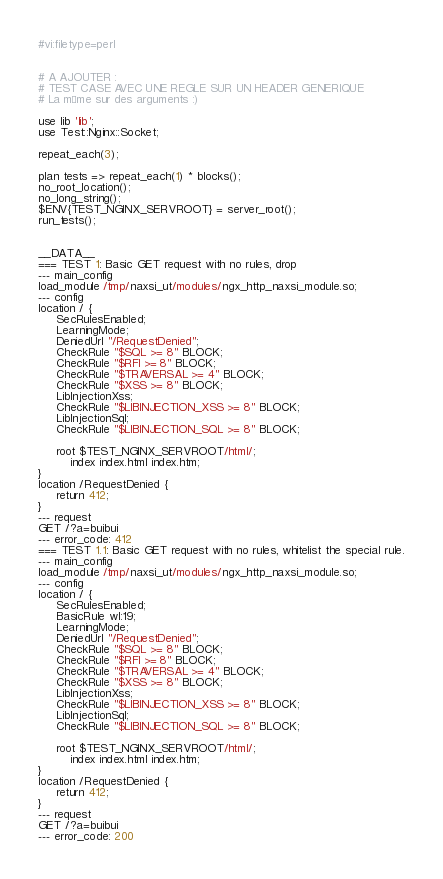Convert code to text. <code><loc_0><loc_0><loc_500><loc_500><_Perl_>#vi:filetype=perl


# A AJOUTER :
# TEST CASE AVEC UNE REGLE SUR UN HEADER GENERIQUE
# La même sur des arguments :)

use lib 'lib';
use Test::Nginx::Socket;

repeat_each(3);

plan tests => repeat_each(1) * blocks();
no_root_location();
no_long_string();
$ENV{TEST_NGINX_SERVROOT} = server_root();
run_tests();


__DATA__
=== TEST 1: Basic GET request with no rules, drop
--- main_config
load_module /tmp/naxsi_ut/modules/ngx_http_naxsi_module.so;
--- config
location / {
	 SecRulesEnabled;
	 LearningMode;
	 DeniedUrl "/RequestDenied";
	 CheckRule "$SQL >= 8" BLOCK;
	 CheckRule "$RFI >= 8" BLOCK;
	 CheckRule "$TRAVERSAL >= 4" BLOCK;
	 CheckRule "$XSS >= 8" BLOCK;
	 LibInjectionXss;
	 CheckRule "$LIBINJECTION_XSS >= 8" BLOCK;
	 LibInjectionSql;
	 CheckRule "$LIBINJECTION_SQL >= 8" BLOCK;

  	 root $TEST_NGINX_SERVROOT/html/;
         index index.html index.htm;
}
location /RequestDenied {
	 return 412;
}
--- request
GET /?a=buibui
--- error_code: 412
=== TEST 1.1: Basic GET request with no rules, whitelist the special rule.
--- main_config
load_module /tmp/naxsi_ut/modules/ngx_http_naxsi_module.so;
--- config
location / {
	 SecRulesEnabled;
	 BasicRule wl:19;
	 LearningMode;
	 DeniedUrl "/RequestDenied";
	 CheckRule "$SQL >= 8" BLOCK;
	 CheckRule "$RFI >= 8" BLOCK;
	 CheckRule "$TRAVERSAL >= 4" BLOCK;
	 CheckRule "$XSS >= 8" BLOCK;
	 LibInjectionXss;
	 CheckRule "$LIBINJECTION_XSS >= 8" BLOCK;
	 LibInjectionSql;
	 CheckRule "$LIBINJECTION_SQL >= 8" BLOCK;

  	 root $TEST_NGINX_SERVROOT/html/;
         index index.html index.htm;
}
location /RequestDenied {
	 return 412;
}
--- request
GET /?a=buibui
--- error_code: 200
</code> 